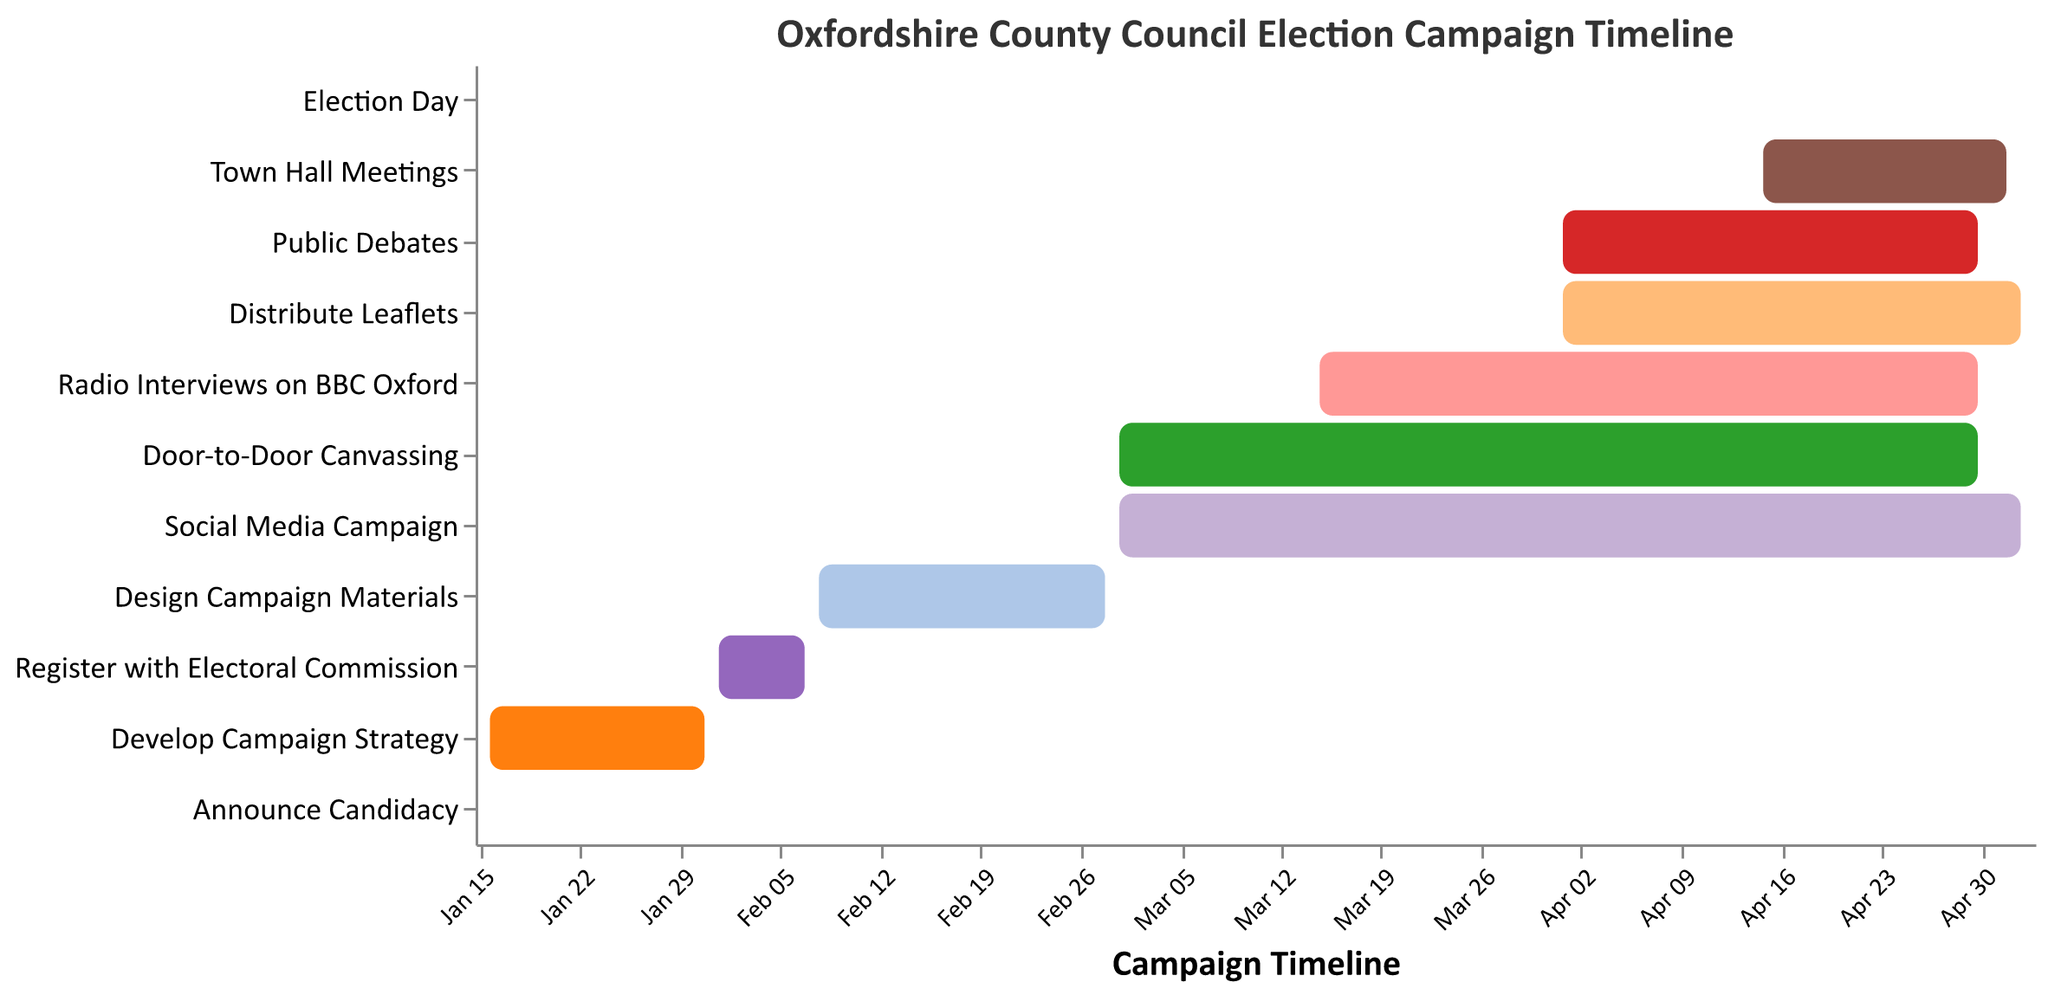What is the title of the Gantt Chart? The title of the Gantt chart is displayed at the top of the chart.
Answer: "Oxfordshire County Council Election Campaign Timeline" How many tasks are plotted in this Gantt Chart? By counting the number of unique tasks listed on the y-axis, we can determine how many tasks are plotted.
Answer: 11 When does the "Door-to-Door Canvassing" activity start and end? Referring to the bar representing the "Door-to-Door Canvassing" task on the chart, we can see its start and end dates.
Answer: Starts on March 1, 2023, and ends on April 30, 2023 Which task lasts the longest in the campaign timeline? By visually comparing the lengths of the bars, we can determine which task spans the most extended period.
Answer: "Social Media Campaign" Are there any tasks that start on the same day? By checking the start dates of each task, we can identify if any tasks share the same start date.
Answer: Yes, "Door-to-Door Canvassing" and "Social Media Campaign" both start on March 1, 2023 Which task ends the closest to Election Day? By comparing the end dates of each task with the date of Election Day (May 4, 2023), we can find the task that ends closest to it.
Answer: "Town Hall Meetings" What is the duration of the "Design Campaign Materials" task? Subtract the start date from the end date of the task to calculate its duration.
Answer: 20 days (from February 8, 2023, to February 28, 2023) Does "Radio Interviews on BBC Oxford" overlap with "Public Debates"? By comparing the date ranges of both tasks, we can check whether any part of their timelines overlap.
Answer: Yes, both tasks overlap between April 1, 2023, and April 30, 2023 How many tasks extend into May 2023? We count the number of tasks which have their end date in May 2023.
Answer: 3 tasks (Social Media Campaign, Distribute Leaflets, and Town Hall Meetings) What is the total duration of the campaign from the first task to Election Day? By calculating the difference between the start date of the first task and the date of Election Day, we can find the total campaign duration.
Answer: 109 days (from January 15, 2023, to May 4, 2023) 